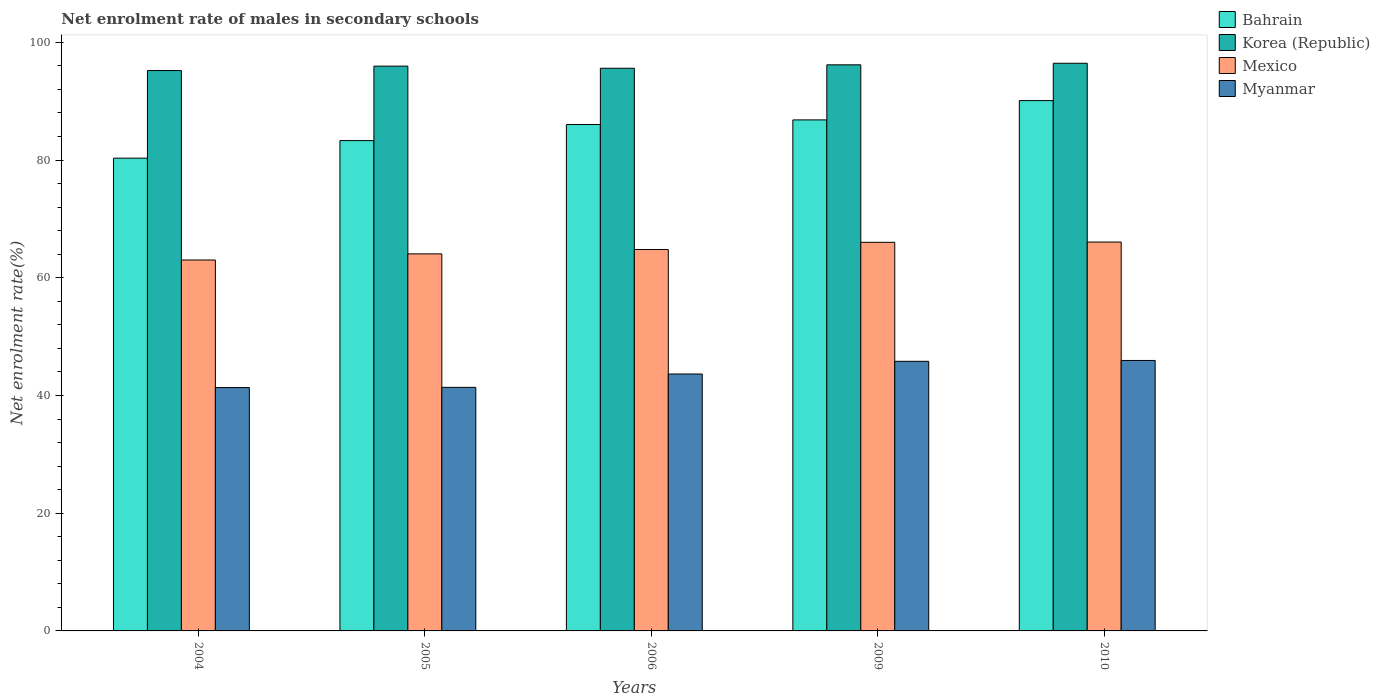How many different coloured bars are there?
Provide a succinct answer. 4. How many groups of bars are there?
Offer a terse response. 5. Are the number of bars per tick equal to the number of legend labels?
Provide a succinct answer. Yes. How many bars are there on the 2nd tick from the left?
Offer a terse response. 4. In how many cases, is the number of bars for a given year not equal to the number of legend labels?
Your answer should be compact. 0. What is the net enrolment rate of males in secondary schools in Bahrain in 2004?
Give a very brief answer. 80.31. Across all years, what is the maximum net enrolment rate of males in secondary schools in Korea (Republic)?
Your response must be concise. 96.44. Across all years, what is the minimum net enrolment rate of males in secondary schools in Mexico?
Your answer should be compact. 63.02. In which year was the net enrolment rate of males in secondary schools in Myanmar maximum?
Keep it short and to the point. 2010. In which year was the net enrolment rate of males in secondary schools in Korea (Republic) minimum?
Ensure brevity in your answer.  2004. What is the total net enrolment rate of males in secondary schools in Mexico in the graph?
Provide a succinct answer. 323.94. What is the difference between the net enrolment rate of males in secondary schools in Myanmar in 2004 and that in 2005?
Offer a very short reply. -0.04. What is the difference between the net enrolment rate of males in secondary schools in Korea (Republic) in 2005 and the net enrolment rate of males in secondary schools in Bahrain in 2004?
Make the answer very short. 15.63. What is the average net enrolment rate of males in secondary schools in Mexico per year?
Give a very brief answer. 64.79. In the year 2009, what is the difference between the net enrolment rate of males in secondary schools in Mexico and net enrolment rate of males in secondary schools in Korea (Republic)?
Offer a very short reply. -30.15. In how many years, is the net enrolment rate of males in secondary schools in Bahrain greater than 4 %?
Offer a very short reply. 5. What is the ratio of the net enrolment rate of males in secondary schools in Mexico in 2004 to that in 2010?
Offer a terse response. 0.95. Is the net enrolment rate of males in secondary schools in Mexico in 2004 less than that in 2005?
Keep it short and to the point. Yes. What is the difference between the highest and the second highest net enrolment rate of males in secondary schools in Bahrain?
Your answer should be compact. 3.28. What is the difference between the highest and the lowest net enrolment rate of males in secondary schools in Mexico?
Offer a very short reply. 3.05. In how many years, is the net enrolment rate of males in secondary schools in Mexico greater than the average net enrolment rate of males in secondary schools in Mexico taken over all years?
Give a very brief answer. 3. Is the sum of the net enrolment rate of males in secondary schools in Myanmar in 2004 and 2005 greater than the maximum net enrolment rate of males in secondary schools in Bahrain across all years?
Your response must be concise. No. What does the 4th bar from the left in 2006 represents?
Your response must be concise. Myanmar. What does the 1st bar from the right in 2010 represents?
Provide a succinct answer. Myanmar. Is it the case that in every year, the sum of the net enrolment rate of males in secondary schools in Korea (Republic) and net enrolment rate of males in secondary schools in Myanmar is greater than the net enrolment rate of males in secondary schools in Bahrain?
Keep it short and to the point. Yes. Are all the bars in the graph horizontal?
Make the answer very short. No. How many years are there in the graph?
Keep it short and to the point. 5. Are the values on the major ticks of Y-axis written in scientific E-notation?
Make the answer very short. No. Does the graph contain grids?
Keep it short and to the point. No. Where does the legend appear in the graph?
Give a very brief answer. Top right. What is the title of the graph?
Give a very brief answer. Net enrolment rate of males in secondary schools. Does "Fragile and conflict affected situations" appear as one of the legend labels in the graph?
Provide a succinct answer. No. What is the label or title of the X-axis?
Give a very brief answer. Years. What is the label or title of the Y-axis?
Provide a short and direct response. Net enrolment rate(%). What is the Net enrolment rate(%) in Bahrain in 2004?
Keep it short and to the point. 80.31. What is the Net enrolment rate(%) of Korea (Republic) in 2004?
Provide a short and direct response. 95.2. What is the Net enrolment rate(%) of Mexico in 2004?
Offer a very short reply. 63.02. What is the Net enrolment rate(%) in Myanmar in 2004?
Provide a short and direct response. 41.34. What is the Net enrolment rate(%) in Bahrain in 2005?
Ensure brevity in your answer.  83.3. What is the Net enrolment rate(%) of Korea (Republic) in 2005?
Keep it short and to the point. 95.95. What is the Net enrolment rate(%) in Mexico in 2005?
Make the answer very short. 64.05. What is the Net enrolment rate(%) of Myanmar in 2005?
Keep it short and to the point. 41.38. What is the Net enrolment rate(%) in Bahrain in 2006?
Offer a terse response. 86.03. What is the Net enrolment rate(%) in Korea (Republic) in 2006?
Ensure brevity in your answer.  95.59. What is the Net enrolment rate(%) of Mexico in 2006?
Your answer should be compact. 64.79. What is the Net enrolment rate(%) of Myanmar in 2006?
Your answer should be compact. 43.65. What is the Net enrolment rate(%) of Bahrain in 2009?
Your response must be concise. 86.81. What is the Net enrolment rate(%) of Korea (Republic) in 2009?
Provide a short and direct response. 96.17. What is the Net enrolment rate(%) of Mexico in 2009?
Give a very brief answer. 66.02. What is the Net enrolment rate(%) of Myanmar in 2009?
Give a very brief answer. 45.8. What is the Net enrolment rate(%) of Bahrain in 2010?
Make the answer very short. 90.09. What is the Net enrolment rate(%) in Korea (Republic) in 2010?
Offer a very short reply. 96.44. What is the Net enrolment rate(%) in Mexico in 2010?
Offer a terse response. 66.06. What is the Net enrolment rate(%) of Myanmar in 2010?
Provide a succinct answer. 45.95. Across all years, what is the maximum Net enrolment rate(%) of Bahrain?
Make the answer very short. 90.09. Across all years, what is the maximum Net enrolment rate(%) in Korea (Republic)?
Make the answer very short. 96.44. Across all years, what is the maximum Net enrolment rate(%) of Mexico?
Offer a very short reply. 66.06. Across all years, what is the maximum Net enrolment rate(%) of Myanmar?
Offer a terse response. 45.95. Across all years, what is the minimum Net enrolment rate(%) in Bahrain?
Your answer should be very brief. 80.31. Across all years, what is the minimum Net enrolment rate(%) of Korea (Republic)?
Provide a short and direct response. 95.2. Across all years, what is the minimum Net enrolment rate(%) of Mexico?
Provide a short and direct response. 63.02. Across all years, what is the minimum Net enrolment rate(%) in Myanmar?
Your response must be concise. 41.34. What is the total Net enrolment rate(%) of Bahrain in the graph?
Offer a very short reply. 426.55. What is the total Net enrolment rate(%) of Korea (Republic) in the graph?
Your answer should be compact. 479.34. What is the total Net enrolment rate(%) of Mexico in the graph?
Your answer should be compact. 323.94. What is the total Net enrolment rate(%) in Myanmar in the graph?
Offer a very short reply. 218.11. What is the difference between the Net enrolment rate(%) of Bahrain in 2004 and that in 2005?
Give a very brief answer. -2.98. What is the difference between the Net enrolment rate(%) of Korea (Republic) in 2004 and that in 2005?
Provide a short and direct response. -0.75. What is the difference between the Net enrolment rate(%) in Mexico in 2004 and that in 2005?
Make the answer very short. -1.04. What is the difference between the Net enrolment rate(%) in Myanmar in 2004 and that in 2005?
Offer a terse response. -0.04. What is the difference between the Net enrolment rate(%) of Bahrain in 2004 and that in 2006?
Keep it short and to the point. -5.72. What is the difference between the Net enrolment rate(%) of Korea (Republic) in 2004 and that in 2006?
Make the answer very short. -0.39. What is the difference between the Net enrolment rate(%) of Mexico in 2004 and that in 2006?
Give a very brief answer. -1.78. What is the difference between the Net enrolment rate(%) of Myanmar in 2004 and that in 2006?
Ensure brevity in your answer.  -2.31. What is the difference between the Net enrolment rate(%) in Bahrain in 2004 and that in 2009?
Provide a short and direct response. -6.5. What is the difference between the Net enrolment rate(%) in Korea (Republic) in 2004 and that in 2009?
Your response must be concise. -0.97. What is the difference between the Net enrolment rate(%) of Mexico in 2004 and that in 2009?
Give a very brief answer. -3. What is the difference between the Net enrolment rate(%) in Myanmar in 2004 and that in 2009?
Give a very brief answer. -4.46. What is the difference between the Net enrolment rate(%) of Bahrain in 2004 and that in 2010?
Provide a short and direct response. -9.78. What is the difference between the Net enrolment rate(%) in Korea (Republic) in 2004 and that in 2010?
Offer a very short reply. -1.24. What is the difference between the Net enrolment rate(%) in Mexico in 2004 and that in 2010?
Make the answer very short. -3.05. What is the difference between the Net enrolment rate(%) of Myanmar in 2004 and that in 2010?
Offer a terse response. -4.6. What is the difference between the Net enrolment rate(%) in Bahrain in 2005 and that in 2006?
Provide a succinct answer. -2.74. What is the difference between the Net enrolment rate(%) of Korea (Republic) in 2005 and that in 2006?
Offer a very short reply. 0.36. What is the difference between the Net enrolment rate(%) in Mexico in 2005 and that in 2006?
Offer a very short reply. -0.74. What is the difference between the Net enrolment rate(%) in Myanmar in 2005 and that in 2006?
Provide a succinct answer. -2.27. What is the difference between the Net enrolment rate(%) of Bahrain in 2005 and that in 2009?
Your answer should be very brief. -3.52. What is the difference between the Net enrolment rate(%) in Korea (Republic) in 2005 and that in 2009?
Provide a succinct answer. -0.22. What is the difference between the Net enrolment rate(%) in Mexico in 2005 and that in 2009?
Offer a terse response. -1.96. What is the difference between the Net enrolment rate(%) in Myanmar in 2005 and that in 2009?
Your answer should be very brief. -4.42. What is the difference between the Net enrolment rate(%) of Bahrain in 2005 and that in 2010?
Your answer should be compact. -6.79. What is the difference between the Net enrolment rate(%) of Korea (Republic) in 2005 and that in 2010?
Keep it short and to the point. -0.49. What is the difference between the Net enrolment rate(%) of Mexico in 2005 and that in 2010?
Keep it short and to the point. -2.01. What is the difference between the Net enrolment rate(%) in Myanmar in 2005 and that in 2010?
Offer a very short reply. -4.57. What is the difference between the Net enrolment rate(%) of Bahrain in 2006 and that in 2009?
Your response must be concise. -0.78. What is the difference between the Net enrolment rate(%) of Korea (Republic) in 2006 and that in 2009?
Ensure brevity in your answer.  -0.59. What is the difference between the Net enrolment rate(%) of Mexico in 2006 and that in 2009?
Make the answer very short. -1.22. What is the difference between the Net enrolment rate(%) of Myanmar in 2006 and that in 2009?
Your response must be concise. -2.15. What is the difference between the Net enrolment rate(%) of Bahrain in 2006 and that in 2010?
Your answer should be compact. -4.06. What is the difference between the Net enrolment rate(%) of Korea (Republic) in 2006 and that in 2010?
Give a very brief answer. -0.85. What is the difference between the Net enrolment rate(%) of Mexico in 2006 and that in 2010?
Your response must be concise. -1.27. What is the difference between the Net enrolment rate(%) of Myanmar in 2006 and that in 2010?
Make the answer very short. -2.3. What is the difference between the Net enrolment rate(%) of Bahrain in 2009 and that in 2010?
Ensure brevity in your answer.  -3.28. What is the difference between the Net enrolment rate(%) in Korea (Republic) in 2009 and that in 2010?
Your answer should be compact. -0.27. What is the difference between the Net enrolment rate(%) of Mexico in 2009 and that in 2010?
Offer a very short reply. -0.05. What is the difference between the Net enrolment rate(%) in Myanmar in 2009 and that in 2010?
Offer a terse response. -0.15. What is the difference between the Net enrolment rate(%) in Bahrain in 2004 and the Net enrolment rate(%) in Korea (Republic) in 2005?
Give a very brief answer. -15.63. What is the difference between the Net enrolment rate(%) of Bahrain in 2004 and the Net enrolment rate(%) of Mexico in 2005?
Your response must be concise. 16.26. What is the difference between the Net enrolment rate(%) in Bahrain in 2004 and the Net enrolment rate(%) in Myanmar in 2005?
Make the answer very short. 38.94. What is the difference between the Net enrolment rate(%) in Korea (Republic) in 2004 and the Net enrolment rate(%) in Mexico in 2005?
Provide a succinct answer. 31.15. What is the difference between the Net enrolment rate(%) of Korea (Republic) in 2004 and the Net enrolment rate(%) of Myanmar in 2005?
Offer a terse response. 53.82. What is the difference between the Net enrolment rate(%) in Mexico in 2004 and the Net enrolment rate(%) in Myanmar in 2005?
Ensure brevity in your answer.  21.64. What is the difference between the Net enrolment rate(%) in Bahrain in 2004 and the Net enrolment rate(%) in Korea (Republic) in 2006?
Provide a short and direct response. -15.27. What is the difference between the Net enrolment rate(%) in Bahrain in 2004 and the Net enrolment rate(%) in Mexico in 2006?
Your answer should be compact. 15.52. What is the difference between the Net enrolment rate(%) in Bahrain in 2004 and the Net enrolment rate(%) in Myanmar in 2006?
Provide a short and direct response. 36.66. What is the difference between the Net enrolment rate(%) in Korea (Republic) in 2004 and the Net enrolment rate(%) in Mexico in 2006?
Give a very brief answer. 30.4. What is the difference between the Net enrolment rate(%) in Korea (Republic) in 2004 and the Net enrolment rate(%) in Myanmar in 2006?
Your answer should be compact. 51.55. What is the difference between the Net enrolment rate(%) in Mexico in 2004 and the Net enrolment rate(%) in Myanmar in 2006?
Your answer should be compact. 19.37. What is the difference between the Net enrolment rate(%) of Bahrain in 2004 and the Net enrolment rate(%) of Korea (Republic) in 2009?
Your answer should be very brief. -15.86. What is the difference between the Net enrolment rate(%) of Bahrain in 2004 and the Net enrolment rate(%) of Mexico in 2009?
Keep it short and to the point. 14.3. What is the difference between the Net enrolment rate(%) of Bahrain in 2004 and the Net enrolment rate(%) of Myanmar in 2009?
Your response must be concise. 34.51. What is the difference between the Net enrolment rate(%) in Korea (Republic) in 2004 and the Net enrolment rate(%) in Mexico in 2009?
Ensure brevity in your answer.  29.18. What is the difference between the Net enrolment rate(%) of Korea (Republic) in 2004 and the Net enrolment rate(%) of Myanmar in 2009?
Provide a succinct answer. 49.4. What is the difference between the Net enrolment rate(%) of Mexico in 2004 and the Net enrolment rate(%) of Myanmar in 2009?
Your response must be concise. 17.22. What is the difference between the Net enrolment rate(%) of Bahrain in 2004 and the Net enrolment rate(%) of Korea (Republic) in 2010?
Offer a terse response. -16.12. What is the difference between the Net enrolment rate(%) of Bahrain in 2004 and the Net enrolment rate(%) of Mexico in 2010?
Offer a terse response. 14.25. What is the difference between the Net enrolment rate(%) in Bahrain in 2004 and the Net enrolment rate(%) in Myanmar in 2010?
Provide a succinct answer. 34.37. What is the difference between the Net enrolment rate(%) in Korea (Republic) in 2004 and the Net enrolment rate(%) in Mexico in 2010?
Provide a succinct answer. 29.13. What is the difference between the Net enrolment rate(%) of Korea (Republic) in 2004 and the Net enrolment rate(%) of Myanmar in 2010?
Keep it short and to the point. 49.25. What is the difference between the Net enrolment rate(%) of Mexico in 2004 and the Net enrolment rate(%) of Myanmar in 2010?
Provide a succinct answer. 17.07. What is the difference between the Net enrolment rate(%) in Bahrain in 2005 and the Net enrolment rate(%) in Korea (Republic) in 2006?
Your response must be concise. -12.29. What is the difference between the Net enrolment rate(%) in Bahrain in 2005 and the Net enrolment rate(%) in Mexico in 2006?
Your answer should be compact. 18.5. What is the difference between the Net enrolment rate(%) in Bahrain in 2005 and the Net enrolment rate(%) in Myanmar in 2006?
Your answer should be very brief. 39.65. What is the difference between the Net enrolment rate(%) in Korea (Republic) in 2005 and the Net enrolment rate(%) in Mexico in 2006?
Offer a very short reply. 31.15. What is the difference between the Net enrolment rate(%) of Korea (Republic) in 2005 and the Net enrolment rate(%) of Myanmar in 2006?
Give a very brief answer. 52.3. What is the difference between the Net enrolment rate(%) in Mexico in 2005 and the Net enrolment rate(%) in Myanmar in 2006?
Keep it short and to the point. 20.4. What is the difference between the Net enrolment rate(%) in Bahrain in 2005 and the Net enrolment rate(%) in Korea (Republic) in 2009?
Offer a very short reply. -12.87. What is the difference between the Net enrolment rate(%) in Bahrain in 2005 and the Net enrolment rate(%) in Mexico in 2009?
Your answer should be very brief. 17.28. What is the difference between the Net enrolment rate(%) of Bahrain in 2005 and the Net enrolment rate(%) of Myanmar in 2009?
Make the answer very short. 37.5. What is the difference between the Net enrolment rate(%) of Korea (Republic) in 2005 and the Net enrolment rate(%) of Mexico in 2009?
Provide a succinct answer. 29.93. What is the difference between the Net enrolment rate(%) in Korea (Republic) in 2005 and the Net enrolment rate(%) in Myanmar in 2009?
Ensure brevity in your answer.  50.15. What is the difference between the Net enrolment rate(%) in Mexico in 2005 and the Net enrolment rate(%) in Myanmar in 2009?
Give a very brief answer. 18.25. What is the difference between the Net enrolment rate(%) in Bahrain in 2005 and the Net enrolment rate(%) in Korea (Republic) in 2010?
Make the answer very short. -13.14. What is the difference between the Net enrolment rate(%) in Bahrain in 2005 and the Net enrolment rate(%) in Mexico in 2010?
Provide a succinct answer. 17.23. What is the difference between the Net enrolment rate(%) in Bahrain in 2005 and the Net enrolment rate(%) in Myanmar in 2010?
Your answer should be very brief. 37.35. What is the difference between the Net enrolment rate(%) in Korea (Republic) in 2005 and the Net enrolment rate(%) in Mexico in 2010?
Your response must be concise. 29.88. What is the difference between the Net enrolment rate(%) in Korea (Republic) in 2005 and the Net enrolment rate(%) in Myanmar in 2010?
Keep it short and to the point. 50. What is the difference between the Net enrolment rate(%) of Mexico in 2005 and the Net enrolment rate(%) of Myanmar in 2010?
Offer a very short reply. 18.11. What is the difference between the Net enrolment rate(%) in Bahrain in 2006 and the Net enrolment rate(%) in Korea (Republic) in 2009?
Offer a terse response. -10.14. What is the difference between the Net enrolment rate(%) in Bahrain in 2006 and the Net enrolment rate(%) in Mexico in 2009?
Offer a terse response. 20.02. What is the difference between the Net enrolment rate(%) of Bahrain in 2006 and the Net enrolment rate(%) of Myanmar in 2009?
Your response must be concise. 40.23. What is the difference between the Net enrolment rate(%) in Korea (Republic) in 2006 and the Net enrolment rate(%) in Mexico in 2009?
Give a very brief answer. 29.57. What is the difference between the Net enrolment rate(%) of Korea (Republic) in 2006 and the Net enrolment rate(%) of Myanmar in 2009?
Make the answer very short. 49.79. What is the difference between the Net enrolment rate(%) in Mexico in 2006 and the Net enrolment rate(%) in Myanmar in 2009?
Keep it short and to the point. 18.99. What is the difference between the Net enrolment rate(%) of Bahrain in 2006 and the Net enrolment rate(%) of Korea (Republic) in 2010?
Your response must be concise. -10.4. What is the difference between the Net enrolment rate(%) of Bahrain in 2006 and the Net enrolment rate(%) of Mexico in 2010?
Make the answer very short. 19.97. What is the difference between the Net enrolment rate(%) in Bahrain in 2006 and the Net enrolment rate(%) in Myanmar in 2010?
Offer a terse response. 40.09. What is the difference between the Net enrolment rate(%) of Korea (Republic) in 2006 and the Net enrolment rate(%) of Mexico in 2010?
Provide a succinct answer. 29.52. What is the difference between the Net enrolment rate(%) in Korea (Republic) in 2006 and the Net enrolment rate(%) in Myanmar in 2010?
Your answer should be very brief. 49.64. What is the difference between the Net enrolment rate(%) of Mexico in 2006 and the Net enrolment rate(%) of Myanmar in 2010?
Keep it short and to the point. 18.85. What is the difference between the Net enrolment rate(%) in Bahrain in 2009 and the Net enrolment rate(%) in Korea (Republic) in 2010?
Give a very brief answer. -9.62. What is the difference between the Net enrolment rate(%) in Bahrain in 2009 and the Net enrolment rate(%) in Mexico in 2010?
Offer a terse response. 20.75. What is the difference between the Net enrolment rate(%) of Bahrain in 2009 and the Net enrolment rate(%) of Myanmar in 2010?
Give a very brief answer. 40.87. What is the difference between the Net enrolment rate(%) in Korea (Republic) in 2009 and the Net enrolment rate(%) in Mexico in 2010?
Give a very brief answer. 30.11. What is the difference between the Net enrolment rate(%) in Korea (Republic) in 2009 and the Net enrolment rate(%) in Myanmar in 2010?
Keep it short and to the point. 50.23. What is the difference between the Net enrolment rate(%) of Mexico in 2009 and the Net enrolment rate(%) of Myanmar in 2010?
Your answer should be very brief. 20.07. What is the average Net enrolment rate(%) of Bahrain per year?
Provide a succinct answer. 85.31. What is the average Net enrolment rate(%) in Korea (Republic) per year?
Provide a short and direct response. 95.87. What is the average Net enrolment rate(%) in Mexico per year?
Offer a very short reply. 64.79. What is the average Net enrolment rate(%) in Myanmar per year?
Keep it short and to the point. 43.62. In the year 2004, what is the difference between the Net enrolment rate(%) in Bahrain and Net enrolment rate(%) in Korea (Republic)?
Provide a succinct answer. -14.89. In the year 2004, what is the difference between the Net enrolment rate(%) of Bahrain and Net enrolment rate(%) of Mexico?
Your answer should be very brief. 17.3. In the year 2004, what is the difference between the Net enrolment rate(%) of Bahrain and Net enrolment rate(%) of Myanmar?
Give a very brief answer. 38.97. In the year 2004, what is the difference between the Net enrolment rate(%) in Korea (Republic) and Net enrolment rate(%) in Mexico?
Provide a short and direct response. 32.18. In the year 2004, what is the difference between the Net enrolment rate(%) in Korea (Republic) and Net enrolment rate(%) in Myanmar?
Offer a terse response. 53.86. In the year 2004, what is the difference between the Net enrolment rate(%) in Mexico and Net enrolment rate(%) in Myanmar?
Offer a very short reply. 21.67. In the year 2005, what is the difference between the Net enrolment rate(%) in Bahrain and Net enrolment rate(%) in Korea (Republic)?
Offer a terse response. -12.65. In the year 2005, what is the difference between the Net enrolment rate(%) of Bahrain and Net enrolment rate(%) of Mexico?
Keep it short and to the point. 19.25. In the year 2005, what is the difference between the Net enrolment rate(%) of Bahrain and Net enrolment rate(%) of Myanmar?
Your response must be concise. 41.92. In the year 2005, what is the difference between the Net enrolment rate(%) of Korea (Republic) and Net enrolment rate(%) of Mexico?
Your answer should be very brief. 31.89. In the year 2005, what is the difference between the Net enrolment rate(%) in Korea (Republic) and Net enrolment rate(%) in Myanmar?
Keep it short and to the point. 54.57. In the year 2005, what is the difference between the Net enrolment rate(%) in Mexico and Net enrolment rate(%) in Myanmar?
Your response must be concise. 22.68. In the year 2006, what is the difference between the Net enrolment rate(%) of Bahrain and Net enrolment rate(%) of Korea (Republic)?
Ensure brevity in your answer.  -9.55. In the year 2006, what is the difference between the Net enrolment rate(%) of Bahrain and Net enrolment rate(%) of Mexico?
Make the answer very short. 21.24. In the year 2006, what is the difference between the Net enrolment rate(%) in Bahrain and Net enrolment rate(%) in Myanmar?
Give a very brief answer. 42.39. In the year 2006, what is the difference between the Net enrolment rate(%) of Korea (Republic) and Net enrolment rate(%) of Mexico?
Provide a short and direct response. 30.79. In the year 2006, what is the difference between the Net enrolment rate(%) of Korea (Republic) and Net enrolment rate(%) of Myanmar?
Keep it short and to the point. 51.94. In the year 2006, what is the difference between the Net enrolment rate(%) of Mexico and Net enrolment rate(%) of Myanmar?
Your answer should be compact. 21.15. In the year 2009, what is the difference between the Net enrolment rate(%) in Bahrain and Net enrolment rate(%) in Korea (Republic)?
Your response must be concise. -9.36. In the year 2009, what is the difference between the Net enrolment rate(%) of Bahrain and Net enrolment rate(%) of Mexico?
Keep it short and to the point. 20.8. In the year 2009, what is the difference between the Net enrolment rate(%) of Bahrain and Net enrolment rate(%) of Myanmar?
Offer a terse response. 41.01. In the year 2009, what is the difference between the Net enrolment rate(%) of Korea (Republic) and Net enrolment rate(%) of Mexico?
Provide a succinct answer. 30.15. In the year 2009, what is the difference between the Net enrolment rate(%) of Korea (Republic) and Net enrolment rate(%) of Myanmar?
Provide a succinct answer. 50.37. In the year 2009, what is the difference between the Net enrolment rate(%) in Mexico and Net enrolment rate(%) in Myanmar?
Ensure brevity in your answer.  20.22. In the year 2010, what is the difference between the Net enrolment rate(%) in Bahrain and Net enrolment rate(%) in Korea (Republic)?
Ensure brevity in your answer.  -6.34. In the year 2010, what is the difference between the Net enrolment rate(%) in Bahrain and Net enrolment rate(%) in Mexico?
Your answer should be very brief. 24.03. In the year 2010, what is the difference between the Net enrolment rate(%) of Bahrain and Net enrolment rate(%) of Myanmar?
Make the answer very short. 44.15. In the year 2010, what is the difference between the Net enrolment rate(%) in Korea (Republic) and Net enrolment rate(%) in Mexico?
Give a very brief answer. 30.37. In the year 2010, what is the difference between the Net enrolment rate(%) of Korea (Republic) and Net enrolment rate(%) of Myanmar?
Your answer should be compact. 50.49. In the year 2010, what is the difference between the Net enrolment rate(%) in Mexico and Net enrolment rate(%) in Myanmar?
Keep it short and to the point. 20.12. What is the ratio of the Net enrolment rate(%) of Bahrain in 2004 to that in 2005?
Ensure brevity in your answer.  0.96. What is the ratio of the Net enrolment rate(%) of Mexico in 2004 to that in 2005?
Ensure brevity in your answer.  0.98. What is the ratio of the Net enrolment rate(%) in Myanmar in 2004 to that in 2005?
Give a very brief answer. 1. What is the ratio of the Net enrolment rate(%) in Bahrain in 2004 to that in 2006?
Give a very brief answer. 0.93. What is the ratio of the Net enrolment rate(%) in Mexico in 2004 to that in 2006?
Provide a succinct answer. 0.97. What is the ratio of the Net enrolment rate(%) of Myanmar in 2004 to that in 2006?
Your response must be concise. 0.95. What is the ratio of the Net enrolment rate(%) in Bahrain in 2004 to that in 2009?
Your answer should be very brief. 0.93. What is the ratio of the Net enrolment rate(%) in Mexico in 2004 to that in 2009?
Offer a terse response. 0.95. What is the ratio of the Net enrolment rate(%) in Myanmar in 2004 to that in 2009?
Keep it short and to the point. 0.9. What is the ratio of the Net enrolment rate(%) in Bahrain in 2004 to that in 2010?
Ensure brevity in your answer.  0.89. What is the ratio of the Net enrolment rate(%) in Korea (Republic) in 2004 to that in 2010?
Offer a terse response. 0.99. What is the ratio of the Net enrolment rate(%) in Mexico in 2004 to that in 2010?
Give a very brief answer. 0.95. What is the ratio of the Net enrolment rate(%) of Myanmar in 2004 to that in 2010?
Offer a terse response. 0.9. What is the ratio of the Net enrolment rate(%) of Bahrain in 2005 to that in 2006?
Offer a terse response. 0.97. What is the ratio of the Net enrolment rate(%) of Myanmar in 2005 to that in 2006?
Make the answer very short. 0.95. What is the ratio of the Net enrolment rate(%) in Bahrain in 2005 to that in 2009?
Ensure brevity in your answer.  0.96. What is the ratio of the Net enrolment rate(%) of Korea (Republic) in 2005 to that in 2009?
Provide a short and direct response. 1. What is the ratio of the Net enrolment rate(%) of Mexico in 2005 to that in 2009?
Provide a short and direct response. 0.97. What is the ratio of the Net enrolment rate(%) of Myanmar in 2005 to that in 2009?
Provide a succinct answer. 0.9. What is the ratio of the Net enrolment rate(%) in Bahrain in 2005 to that in 2010?
Make the answer very short. 0.92. What is the ratio of the Net enrolment rate(%) in Mexico in 2005 to that in 2010?
Offer a terse response. 0.97. What is the ratio of the Net enrolment rate(%) in Myanmar in 2005 to that in 2010?
Offer a terse response. 0.9. What is the ratio of the Net enrolment rate(%) in Bahrain in 2006 to that in 2009?
Ensure brevity in your answer.  0.99. What is the ratio of the Net enrolment rate(%) in Korea (Republic) in 2006 to that in 2009?
Your answer should be compact. 0.99. What is the ratio of the Net enrolment rate(%) of Mexico in 2006 to that in 2009?
Make the answer very short. 0.98. What is the ratio of the Net enrolment rate(%) of Myanmar in 2006 to that in 2009?
Your response must be concise. 0.95. What is the ratio of the Net enrolment rate(%) of Bahrain in 2006 to that in 2010?
Your response must be concise. 0.95. What is the ratio of the Net enrolment rate(%) of Korea (Republic) in 2006 to that in 2010?
Ensure brevity in your answer.  0.99. What is the ratio of the Net enrolment rate(%) in Mexico in 2006 to that in 2010?
Your answer should be very brief. 0.98. What is the ratio of the Net enrolment rate(%) of Bahrain in 2009 to that in 2010?
Ensure brevity in your answer.  0.96. What is the ratio of the Net enrolment rate(%) in Korea (Republic) in 2009 to that in 2010?
Make the answer very short. 1. What is the ratio of the Net enrolment rate(%) of Myanmar in 2009 to that in 2010?
Your response must be concise. 1. What is the difference between the highest and the second highest Net enrolment rate(%) of Bahrain?
Ensure brevity in your answer.  3.28. What is the difference between the highest and the second highest Net enrolment rate(%) of Korea (Republic)?
Offer a terse response. 0.27. What is the difference between the highest and the second highest Net enrolment rate(%) of Mexico?
Offer a very short reply. 0.05. What is the difference between the highest and the second highest Net enrolment rate(%) in Myanmar?
Your answer should be compact. 0.15. What is the difference between the highest and the lowest Net enrolment rate(%) of Bahrain?
Ensure brevity in your answer.  9.78. What is the difference between the highest and the lowest Net enrolment rate(%) of Korea (Republic)?
Make the answer very short. 1.24. What is the difference between the highest and the lowest Net enrolment rate(%) of Mexico?
Offer a terse response. 3.05. What is the difference between the highest and the lowest Net enrolment rate(%) of Myanmar?
Your answer should be very brief. 4.6. 